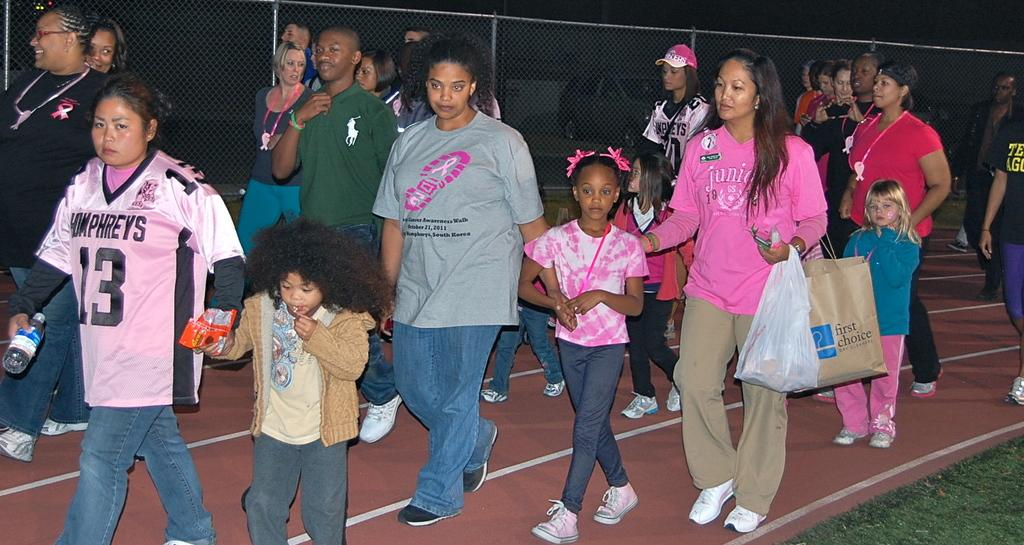<image>
Present a compact description of the photo's key features. People wearing pink for charity event for breast cancer. 